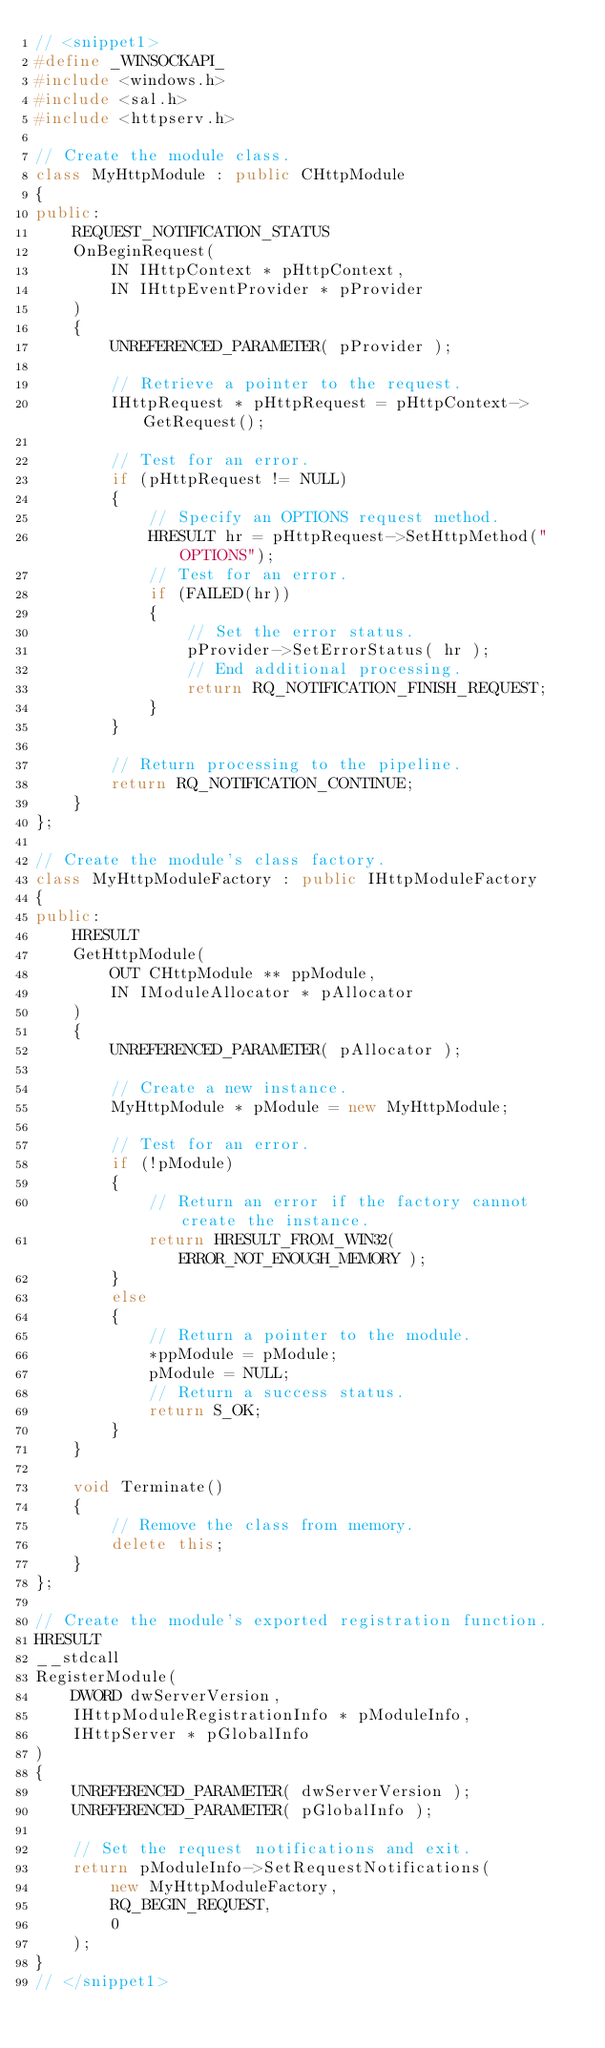<code> <loc_0><loc_0><loc_500><loc_500><_C++_>// <snippet1>
#define _WINSOCKAPI_
#include <windows.h>
#include <sal.h>
#include <httpserv.h>

// Create the module class.
class MyHttpModule : public CHttpModule
{
public:
    REQUEST_NOTIFICATION_STATUS
    OnBeginRequest(
        IN IHttpContext * pHttpContext,
        IN IHttpEventProvider * pProvider
    )
    {
        UNREFERENCED_PARAMETER( pProvider );

        // Retrieve a pointer to the request.
        IHttpRequest * pHttpRequest = pHttpContext->GetRequest();

        // Test for an error.
        if (pHttpRequest != NULL)
        {
            // Specify an OPTIONS request method.
            HRESULT hr = pHttpRequest->SetHttpMethod("OPTIONS");
            // Test for an error.
            if (FAILED(hr))
            {
                // Set the error status.
                pProvider->SetErrorStatus( hr );
                // End additional processing.
                return RQ_NOTIFICATION_FINISH_REQUEST;
            }
        }

        // Return processing to the pipeline.
        return RQ_NOTIFICATION_CONTINUE;
    }
};

// Create the module's class factory.
class MyHttpModuleFactory : public IHttpModuleFactory
{
public:
    HRESULT
    GetHttpModule(
        OUT CHttpModule ** ppModule, 
        IN IModuleAllocator * pAllocator
    )
    {
        UNREFERENCED_PARAMETER( pAllocator );

        // Create a new instance.
        MyHttpModule * pModule = new MyHttpModule;

        // Test for an error.
        if (!pModule)
        {
            // Return an error if the factory cannot create the instance.
            return HRESULT_FROM_WIN32( ERROR_NOT_ENOUGH_MEMORY );
        }
        else
        {
            // Return a pointer to the module.
            *ppModule = pModule;
            pModule = NULL;
            // Return a success status.
            return S_OK;
        }            
    }

    void Terminate()
    {
        // Remove the class from memory.
        delete this;
    }
};

// Create the module's exported registration function.
HRESULT
__stdcall
RegisterModule(
    DWORD dwServerVersion,
    IHttpModuleRegistrationInfo * pModuleInfo,
    IHttpServer * pGlobalInfo
)
{
    UNREFERENCED_PARAMETER( dwServerVersion );
    UNREFERENCED_PARAMETER( pGlobalInfo );

    // Set the request notifications and exit.
    return pModuleInfo->SetRequestNotifications(
        new MyHttpModuleFactory,
        RQ_BEGIN_REQUEST,
        0
    );
}
// </snippet1></code> 